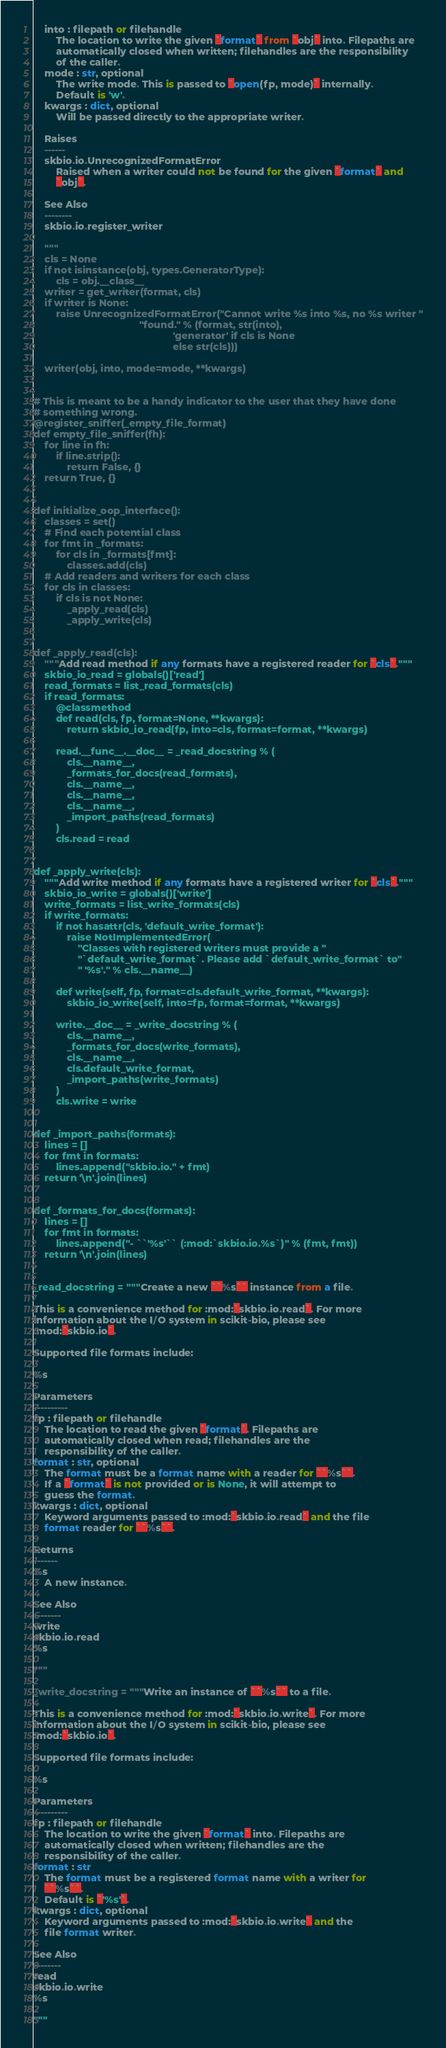Convert code to text. <code><loc_0><loc_0><loc_500><loc_500><_Python_>    into : filepath or filehandle
        The location to write the given `format` from `obj` into. Filepaths are
        automatically closed when written; filehandles are the responsibility
        of the caller.
    mode : str, optional
        The write mode. This is passed to `open(fp, mode)` internally.
        Default is 'w'.
    kwargs : dict, optional
        Will be passed directly to the appropriate writer.

    Raises
    ------
    skbio.io.UnrecognizedFormatError
        Raised when a writer could not be found for the given `format` and
        `obj`.

    See Also
    --------
    skbio.io.register_writer

    """
    cls = None
    if not isinstance(obj, types.GeneratorType):
        cls = obj.__class__
    writer = get_writer(format, cls)
    if writer is None:
        raise UnrecognizedFormatError("Cannot write %s into %s, no %s writer "
                                      "found." % (format, str(into),
                                                  'generator' if cls is None
                                                  else str(cls)))

    writer(obj, into, mode=mode, **kwargs)


# This is meant to be a handy indicator to the user that they have done
# something wrong.
@register_sniffer(_empty_file_format)
def empty_file_sniffer(fh):
    for line in fh:
        if line.strip():
            return False, {}
    return True, {}


def initialize_oop_interface():
    classes = set()
    # Find each potential class
    for fmt in _formats:
        for cls in _formats[fmt]:
            classes.add(cls)
    # Add readers and writers for each class
    for cls in classes:
        if cls is not None:
            _apply_read(cls)
            _apply_write(cls)


def _apply_read(cls):
    """Add read method if any formats have a registered reader for `cls`."""
    skbio_io_read = globals()['read']
    read_formats = list_read_formats(cls)
    if read_formats:
        @classmethod
        def read(cls, fp, format=None, **kwargs):
            return skbio_io_read(fp, into=cls, format=format, **kwargs)

        read.__func__.__doc__ = _read_docstring % (
            cls.__name__,
            _formats_for_docs(read_formats),
            cls.__name__,
            cls.__name__,
            cls.__name__,
            _import_paths(read_formats)
        )
        cls.read = read


def _apply_write(cls):
    """Add write method if any formats have a registered writer for `cls`."""
    skbio_io_write = globals()['write']
    write_formats = list_write_formats(cls)
    if write_formats:
        if not hasattr(cls, 'default_write_format'):
            raise NotImplementedError(
                "Classes with registered writers must provide a "
                "`default_write_format`. Please add `default_write_format` to"
                " '%s'." % cls.__name__)

        def write(self, fp, format=cls.default_write_format, **kwargs):
            skbio_io_write(self, into=fp, format=format, **kwargs)

        write.__doc__ = _write_docstring % (
            cls.__name__,
            _formats_for_docs(write_formats),
            cls.__name__,
            cls.default_write_format,
            _import_paths(write_formats)
        )
        cls.write = write


def _import_paths(formats):
    lines = []
    for fmt in formats:
        lines.append("skbio.io." + fmt)
    return '\n'.join(lines)


def _formats_for_docs(formats):
    lines = []
    for fmt in formats:
        lines.append("- ``'%s'`` (:mod:`skbio.io.%s`)" % (fmt, fmt))
    return '\n'.join(lines)


_read_docstring = """Create a new ``%s`` instance from a file.

This is a convenience method for :mod:`skbio.io.read`. For more
information about the I/O system in scikit-bio, please see
:mod:`skbio.io`.

Supported file formats include:

%s

Parameters
----------
fp : filepath or filehandle
    The location to read the given `format`. Filepaths are
    automatically closed when read; filehandles are the
    responsibility of the caller.
format : str, optional
    The format must be a format name with a reader for ``%s``.
    If a `format` is not provided or is None, it will attempt to
    guess the format.
kwargs : dict, optional
    Keyword arguments passed to :mod:`skbio.io.read` and the file
    format reader for ``%s``.

Returns
-------
%s
    A new instance.

See Also
--------
write
skbio.io.read
%s

"""

_write_docstring = """Write an instance of ``%s`` to a file.

This is a convenience method for :mod:`skbio.io.write`. For more
information about the I/O system in scikit-bio, please see
:mod:`skbio.io`.

Supported file formats include:

%s

Parameters
----------
fp : filepath or filehandle
    The location to write the given `format` into. Filepaths are
    automatically closed when written; filehandles are the
    responsibility of the caller.
format : str
    The format must be a registered format name with a writer for
    ``%s``.
    Default is `'%s'`.
kwargs : dict, optional
    Keyword arguments passed to :mod:`skbio.io.write` and the
    file format writer.

See Also
--------
read
skbio.io.write
%s

"""
</code> 